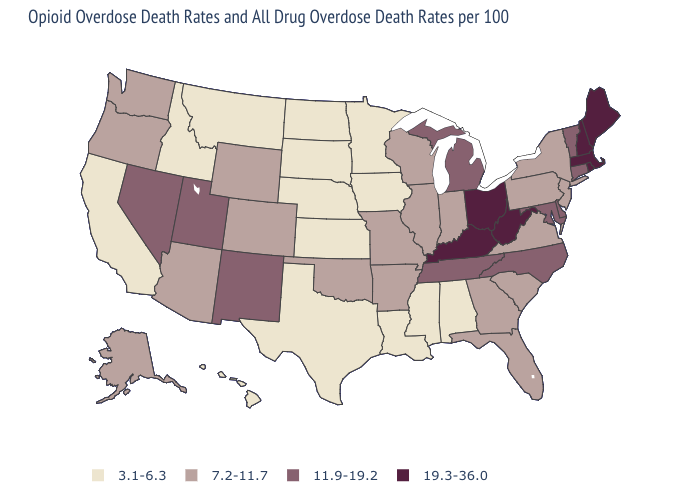Name the states that have a value in the range 11.9-19.2?
Be succinct. Connecticut, Delaware, Maryland, Michigan, Nevada, New Mexico, North Carolina, Tennessee, Utah, Vermont. Name the states that have a value in the range 3.1-6.3?
Be succinct. Alabama, California, Hawaii, Idaho, Iowa, Kansas, Louisiana, Minnesota, Mississippi, Montana, Nebraska, North Dakota, South Dakota, Texas. What is the value of Florida?
Quick response, please. 7.2-11.7. What is the value of New York?
Give a very brief answer. 7.2-11.7. Does Missouri have a higher value than Iowa?
Keep it brief. Yes. What is the value of New York?
Keep it brief. 7.2-11.7. What is the value of Minnesota?
Answer briefly. 3.1-6.3. Among the states that border Massachusetts , does Rhode Island have the highest value?
Keep it brief. Yes. Among the states that border California , which have the highest value?
Answer briefly. Nevada. Which states have the highest value in the USA?
Be succinct. Kentucky, Maine, Massachusetts, New Hampshire, Ohio, Rhode Island, West Virginia. Does Pennsylvania have a lower value than North Dakota?
Quick response, please. No. What is the value of Georgia?
Be succinct. 7.2-11.7. Does Oklahoma have a higher value than Michigan?
Write a very short answer. No. What is the highest value in the USA?
Write a very short answer. 19.3-36.0. Among the states that border Colorado , does Utah have the highest value?
Quick response, please. Yes. 